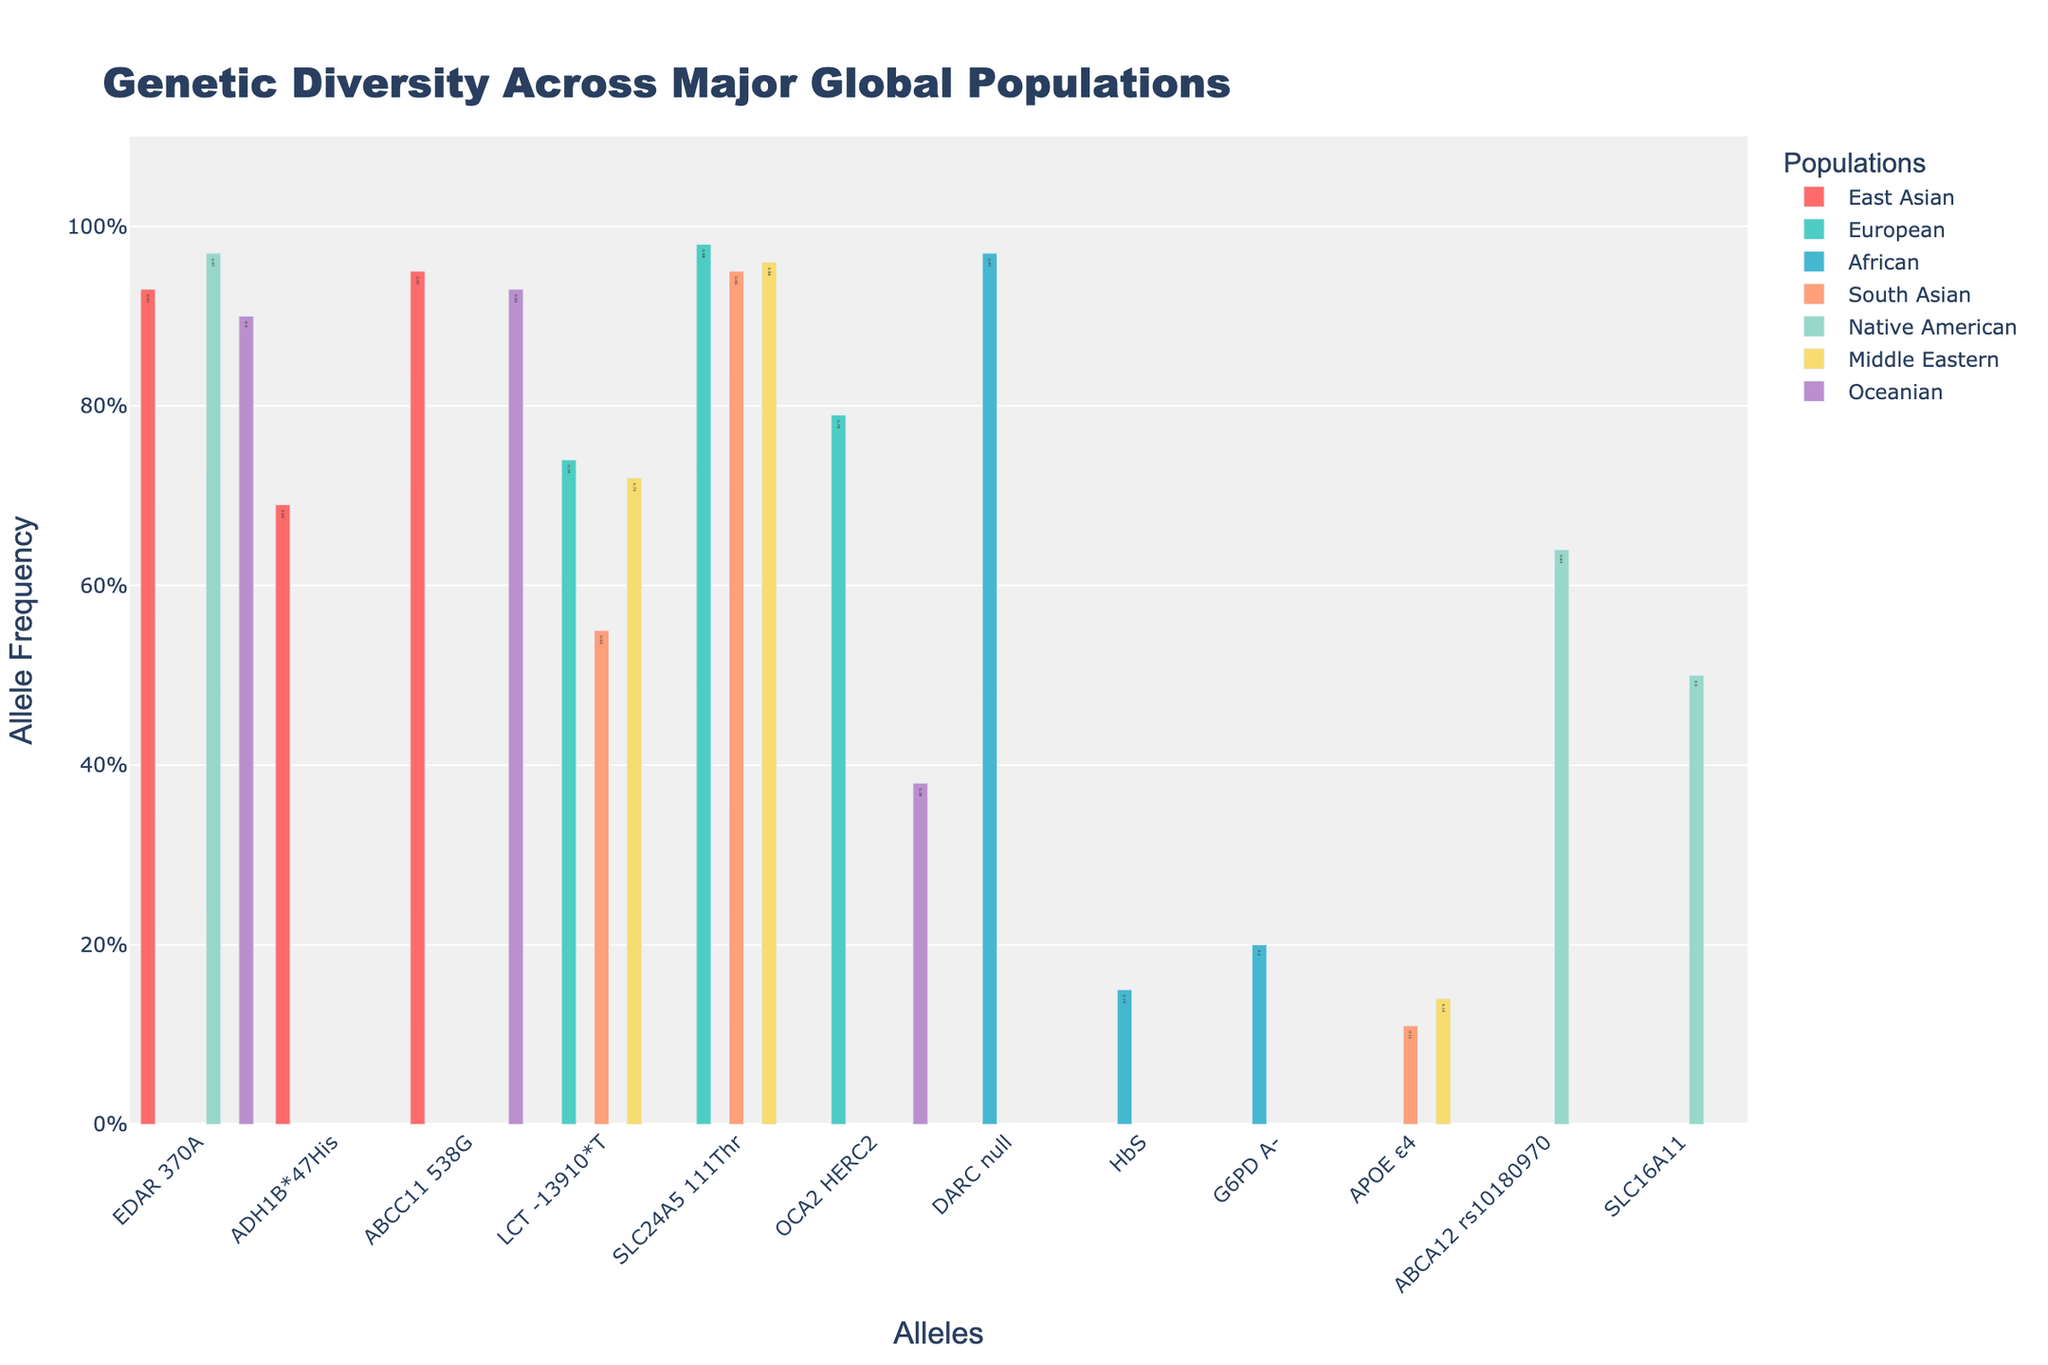What is the allele with the highest frequency in East Asian populations? The bars for East Asian populations show the frequencies of different alleles. By comparing their heights, the ABCC11 538G allele, with a frequency of 0.95, is the highest.
Answer: ABCC11 538G Which population exhibits the highest frequency of the allele OCA2 HERC2? To determine this, we look for the bar representing the OCA2 HERC2 allele in each population. The European population has the highest frequency bar for this allele at 0.79.
Answer: European What is the difference in frequency of the allele LCT -13910*T between European and South Asian populations? Find the LCT -13910*T allele in both populations and calculate the difference in their frequencies: 0.74 (European) - 0.55 (South Asian) = 0.19.
Answer: 0.19 Which population has the lowest frequency of the allele APOE ε4? Compare the bars representing the APOE ε4 allele across the populations. The South Asian population has the lowest frequency at 0.11.
Answer: South Asian What is the average frequency of the allele EDAR 370A across East Asian and Oceanian populations? Add the frequencies of EDAR 370A in both populations and divide by 2: (0.93 + 0.90)/2 = 0.915.
Answer: 0.915 Are there any populations with the same exact frequency for any allele? If so, which one(s)? By inspecting the figure, the allele ABCC11 538G has a frequency of 0.93 in both East Asian and Oceanian populations.
Answer: Yes, East Asian and Oceanian What is the sum of the frequencies of the alleles DARC null and HbS in African populations? Add the frequencies of DARC null and HbS in African populations: 0.97 + 0.15 = 1.12.
Answer: 1.12 Which allele has a frequency of exactly 0.50 in Native American populations? Look for the bar representing an allele with a height corresponding to 0.50 in Native American populations; it’s SLC16A11.
Answer: SLC16A11 